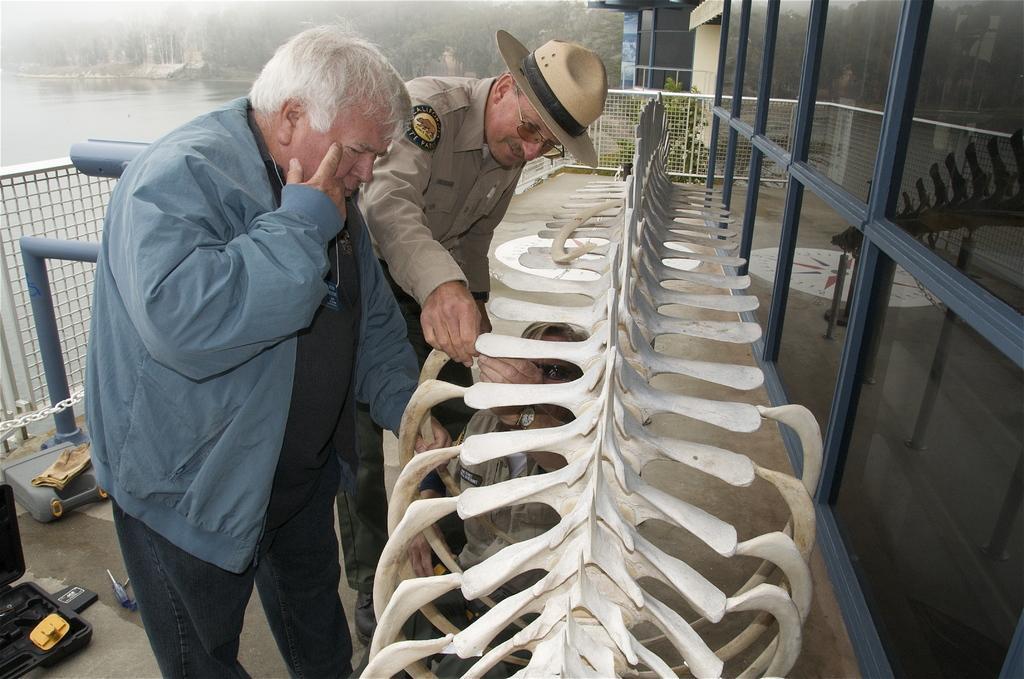Please provide a concise description of this image. In the foreground of this image, there are three persons near a skeleton of an animal. In the background, there are poles, fencing, water, trees and the glass wall. 